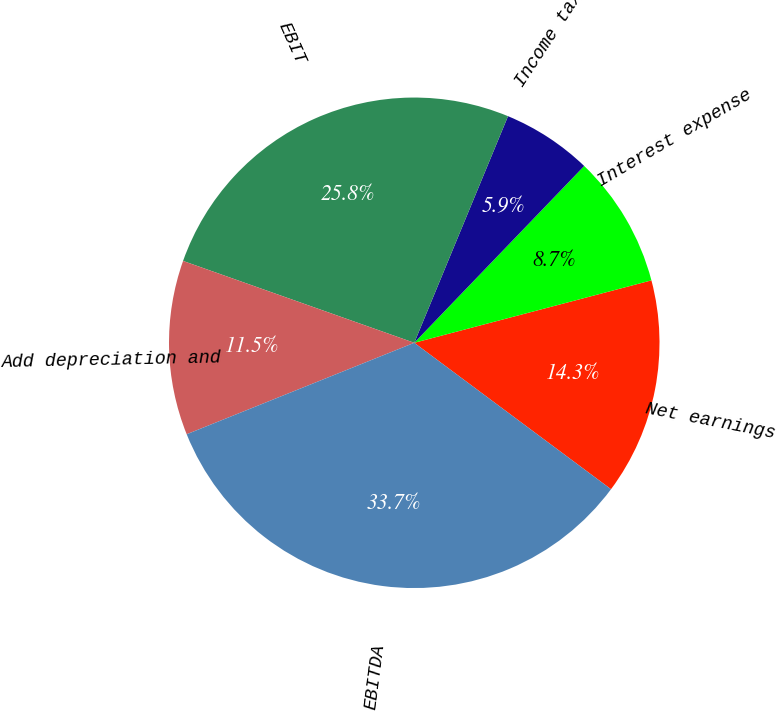Convert chart to OTSL. <chart><loc_0><loc_0><loc_500><loc_500><pie_chart><fcel>Net earnings<fcel>Interest expense<fcel>Income tax provision<fcel>EBIT<fcel>Add depreciation and<fcel>EBITDA<nl><fcel>14.28%<fcel>8.72%<fcel>5.94%<fcel>25.83%<fcel>11.5%<fcel>33.74%<nl></chart> 